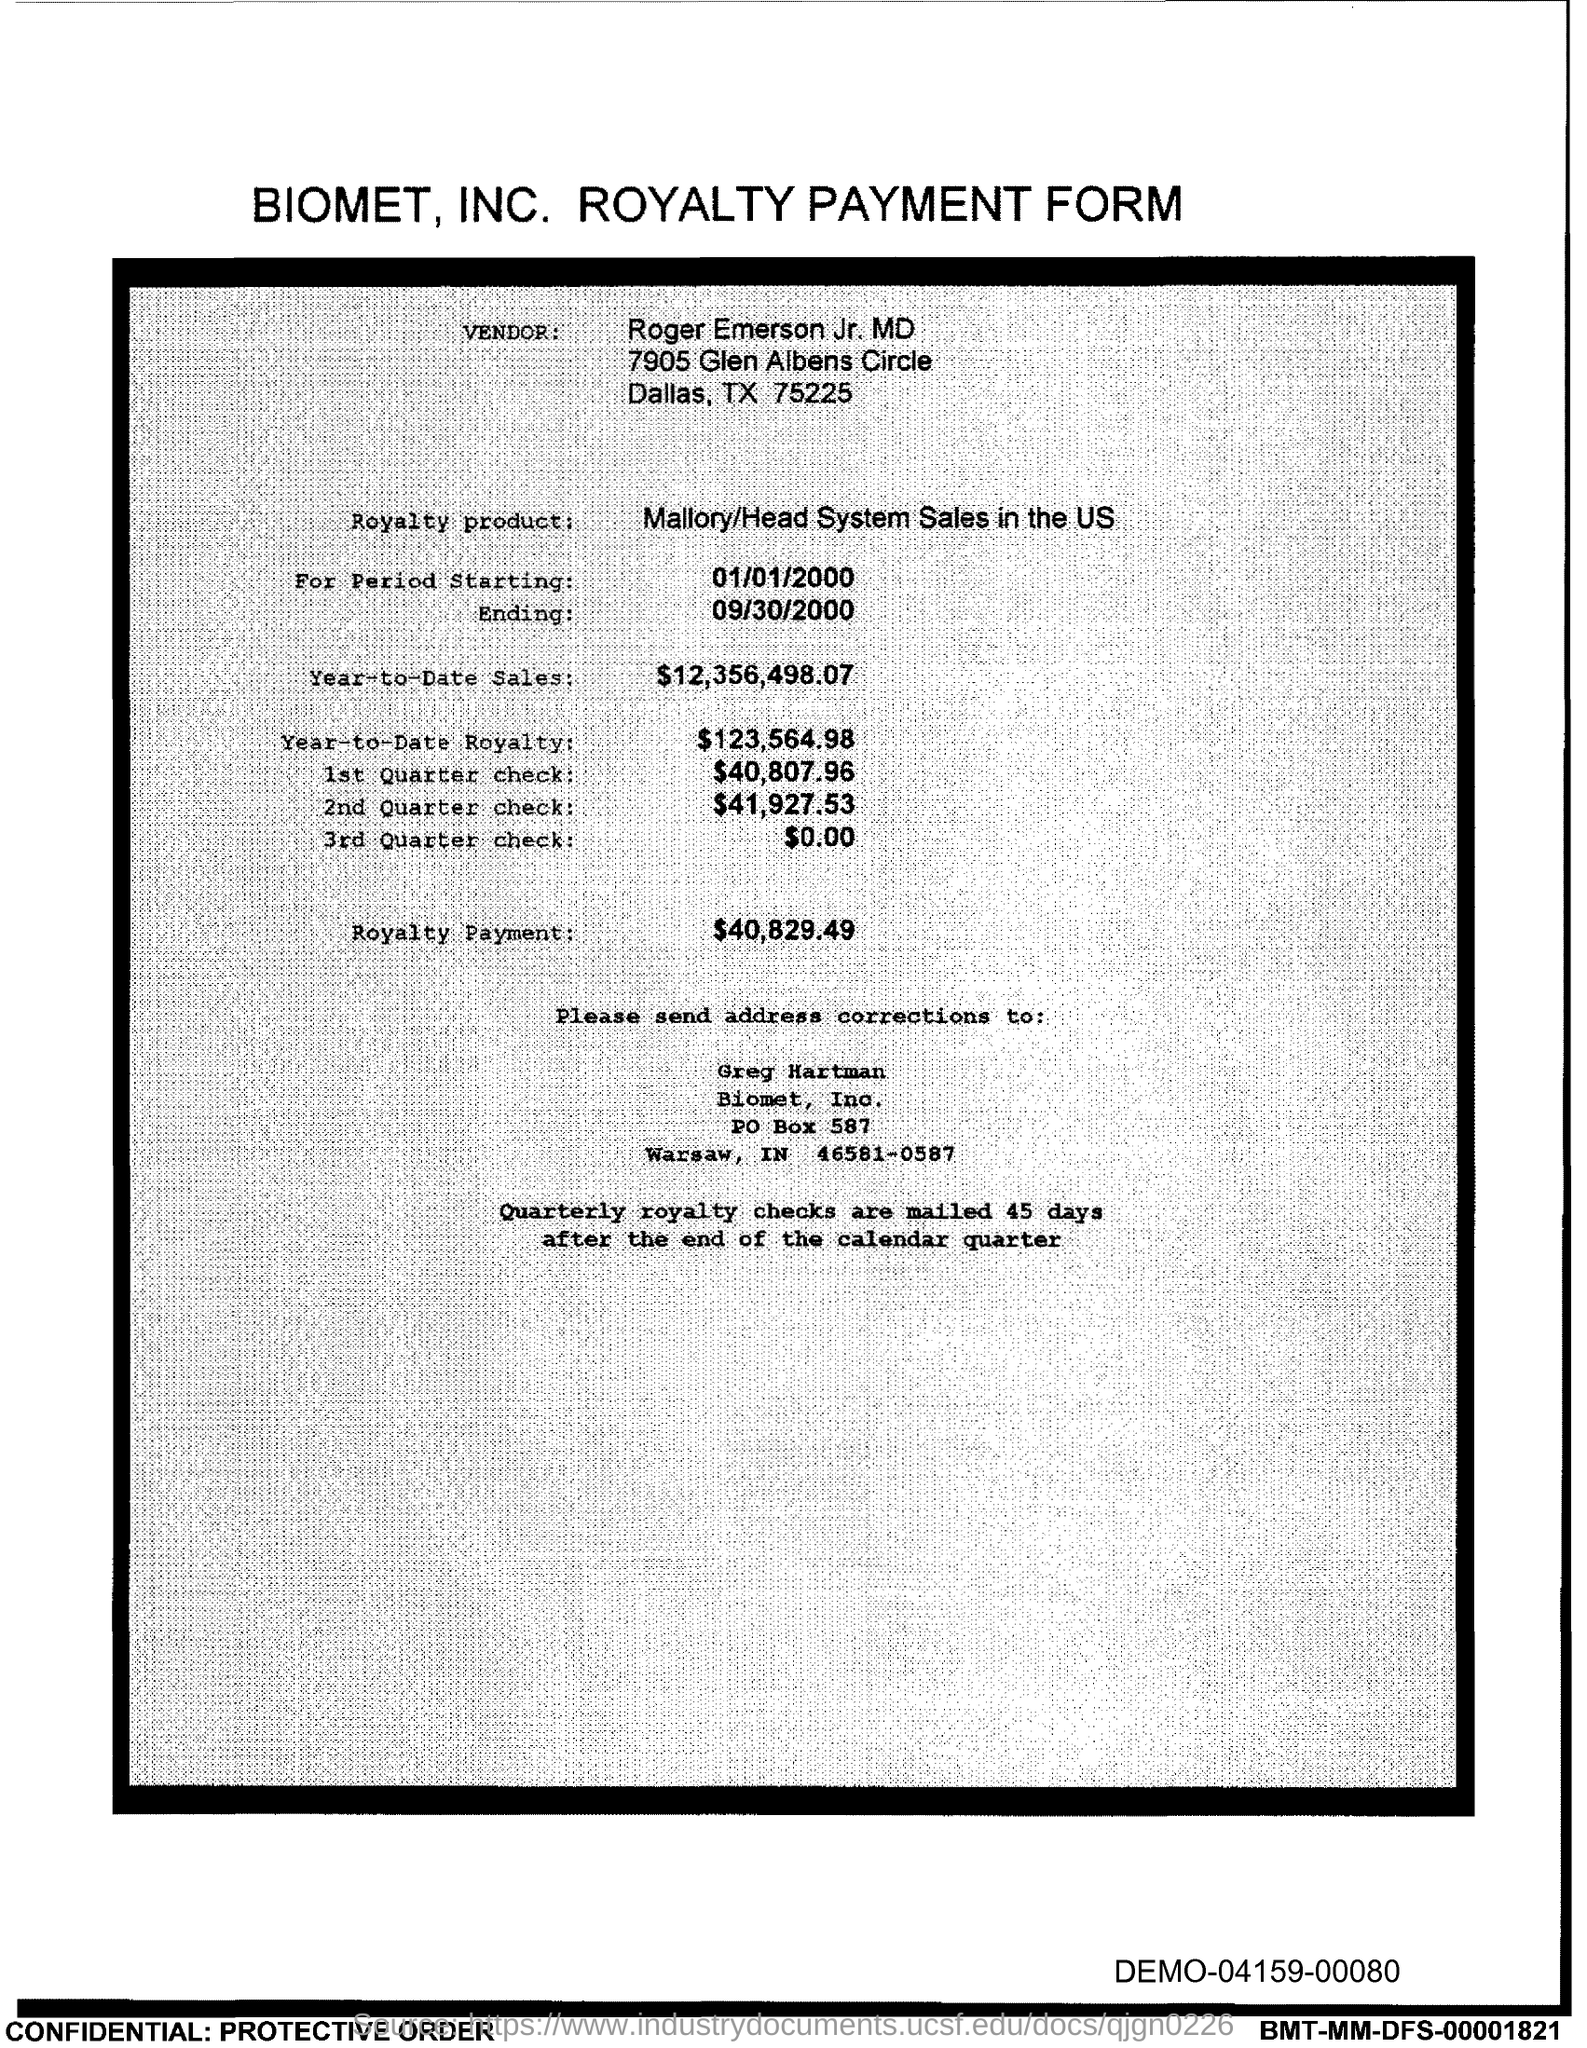What is the start date of the royalty period?
Offer a terse response. 01/01/2000. What is the Year-to-Date Sales of the royalty product?
Your answer should be very brief. $12,356,498.07. What is the Year-to-Date royalty of the product?
Your answer should be compact. $123,564.98. What is the amount of 1st quarter check mentioned in the form?
Your answer should be compact. $40,807.96. What is the amount of 3rd Quarter check given in the form?
Ensure brevity in your answer.  $0.00. What is the end date of the royalty period?
Your answer should be very brief. 09/30/2000. What is the royalty payment of the product mentioned in the form?
Your answer should be very brief. $40,829.49. 